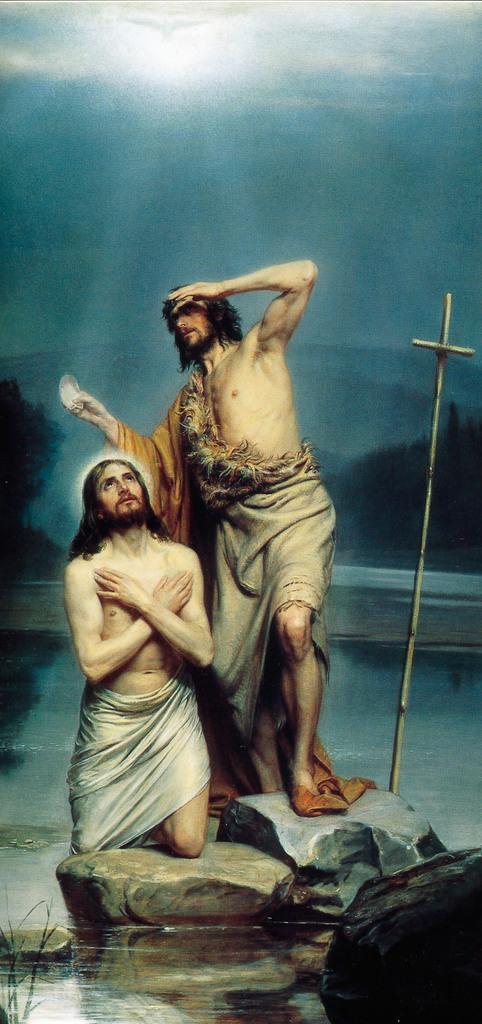Describe this image in one or two sentences. In this picture we can see two people, rocks, water, sticks, trees and in the background we can see the sky. 